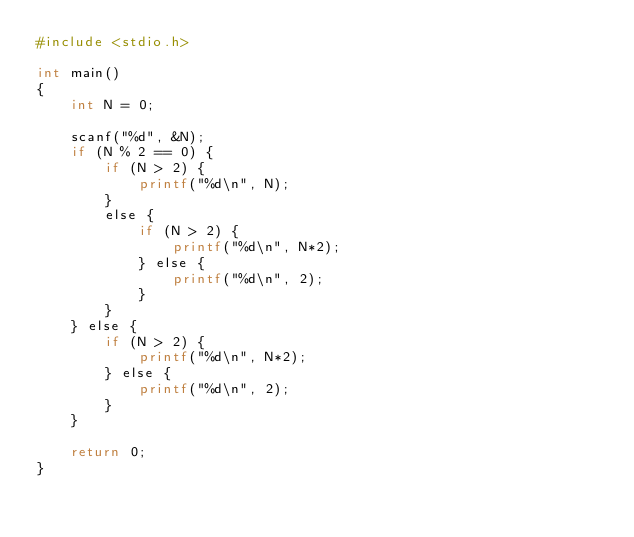<code> <loc_0><loc_0><loc_500><loc_500><_Awk_>#include <stdio.h>

int main()
{
    int N = 0;

    scanf("%d", &N);
    if (N % 2 == 0) {
        if (N > 2) {
            printf("%d\n", N);
        }
        else {
            if (N > 2) {
                printf("%d\n", N*2);
            } else {
                printf("%d\n", 2);
            }
        }
    } else {
        if (N > 2) {
            printf("%d\n", N*2);
        } else {
            printf("%d\n", 2);
        }
    }

    return 0;
}
</code> 